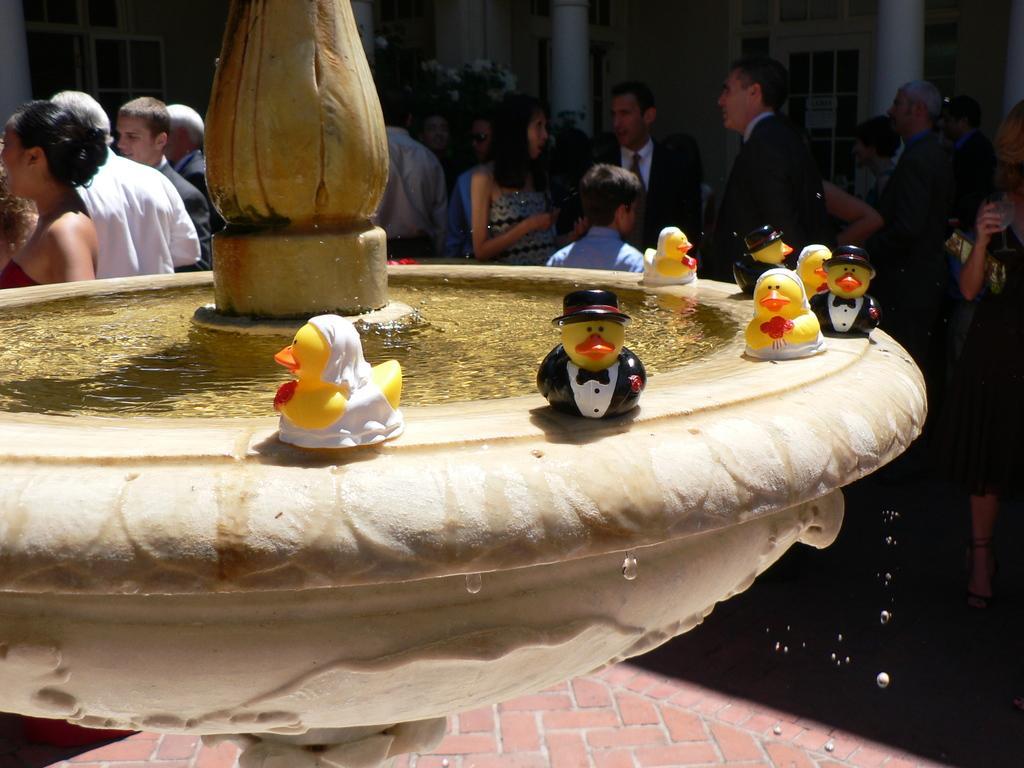Please provide a concise description of this image. In this image we can see people standing on the floor. In the background we can see fountain and toys placed on it. 